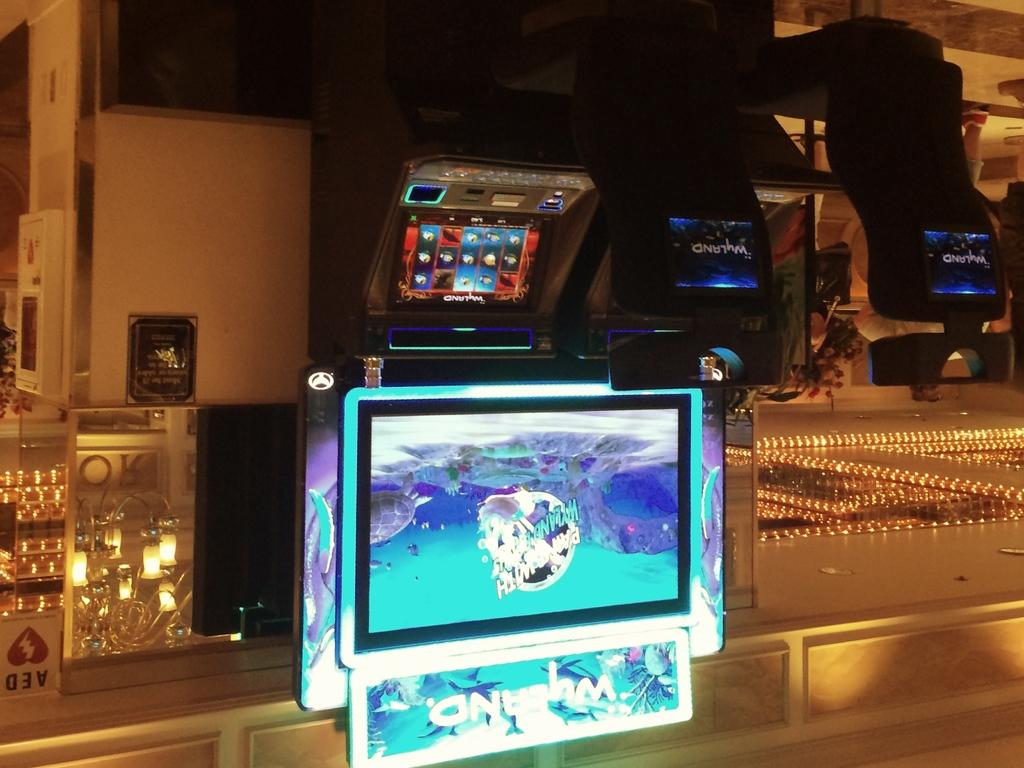What can be seen in the image in terms of electronic devices? There are many screens in the image. What object is located on the left side of the image? There is a mirror on the left side of the image. What is reflected in the mirror? The mirror has a lamp reflection on it. What can be seen on the right side of the image? There are lights on the right side of the image. What type of background is present in the image? There is a wall in the image. Can you tell me how many bubbles are floating around the screens in the image? There are no bubbles present in the image; it features screens, a mirror, a lamp reflection, lights, and a wall. What type of flock is visible in the image? There is no flock present in the image. 